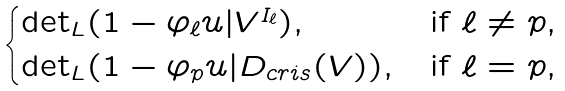<formula> <loc_0><loc_0><loc_500><loc_500>\begin{cases} \det _ { L } ( 1 - \varphi _ { \ell } u | V ^ { I _ { \ell } } ) , & \text {if $\ell\neq p,$} \\ \det _ { L } ( 1 - \varphi _ { p } u | D _ { c r i s } ( V ) ) , & \text {if $\ell = p$,} \end{cases}</formula> 